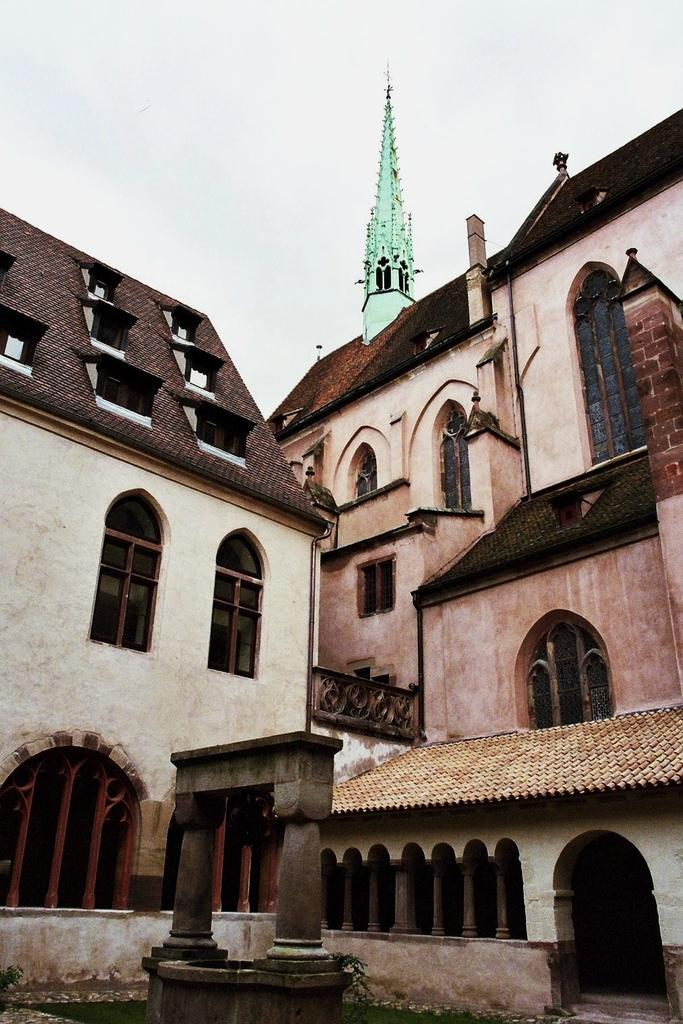How many buildings can be seen in the image? There are two buildings in the image. What features do the buildings have? The buildings have windows and arches. Can you describe any other elements around the buildings? Unfortunately, the provided facts do not specify any other elements around the buildings. How does the kitty show respect to the buildings in the image? There is no kitty present in the image, so it cannot show respect or interact with the buildings in any way. 